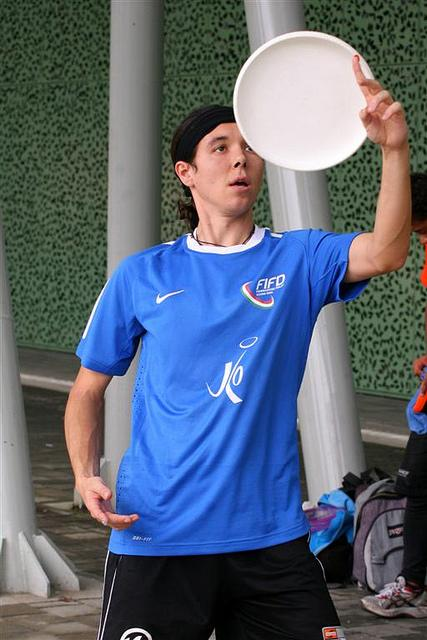What is he doing with the frisbee?

Choices:
A) holding it
B) throwing it
C) balancing it
D) twirling it balancing it 